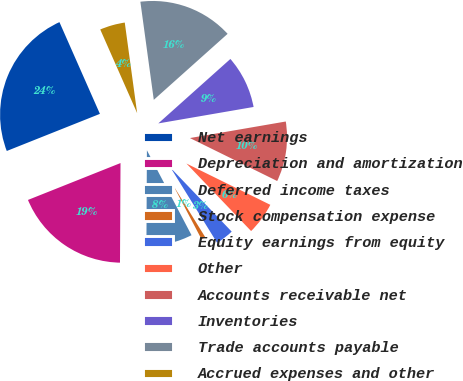Convert chart. <chart><loc_0><loc_0><loc_500><loc_500><pie_chart><fcel>Net earnings<fcel>Depreciation and amortization<fcel>Deferred income taxes<fcel>Stock compensation expense<fcel>Equity earnings from equity<fcel>Other<fcel>Accounts receivable net<fcel>Inventories<fcel>Trade accounts payable<fcel>Accrued expenses and other<nl><fcel>24.42%<fcel>18.88%<fcel>7.78%<fcel>1.12%<fcel>3.34%<fcel>5.56%<fcel>10.0%<fcel>8.89%<fcel>15.55%<fcel>4.45%<nl></chart> 